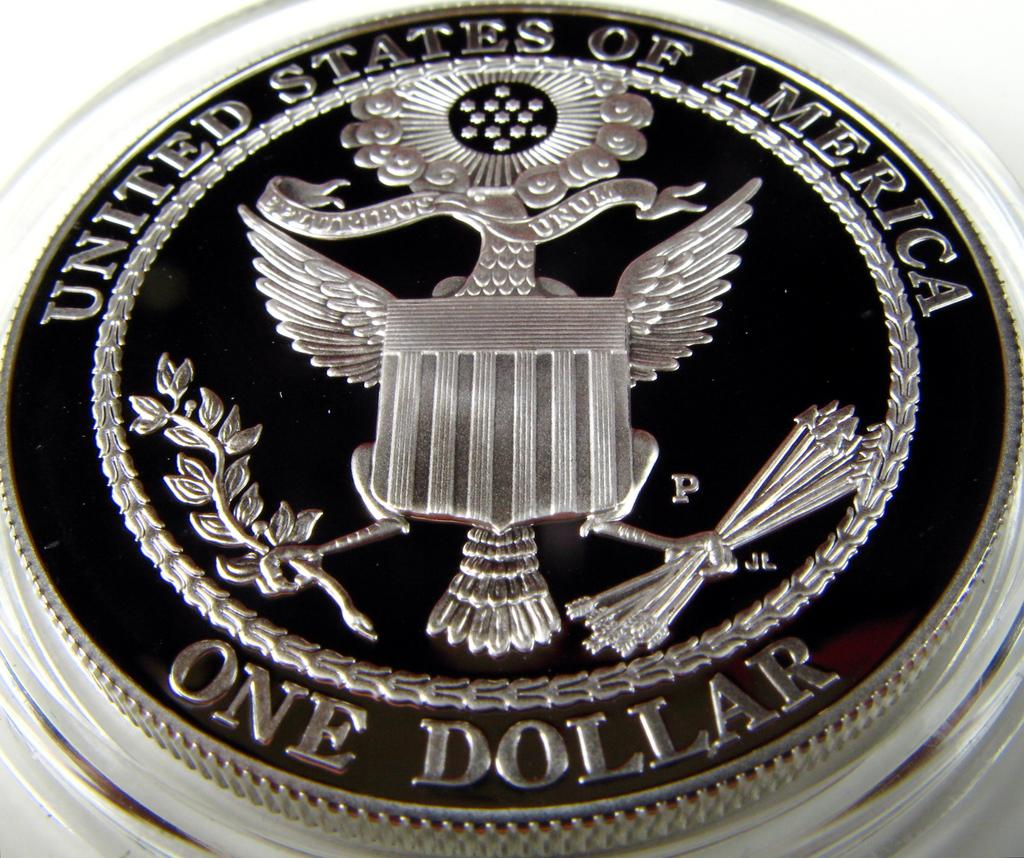Provide a one-sentence caption for the provided image. A beautiful Silver United States one dollar coin. 